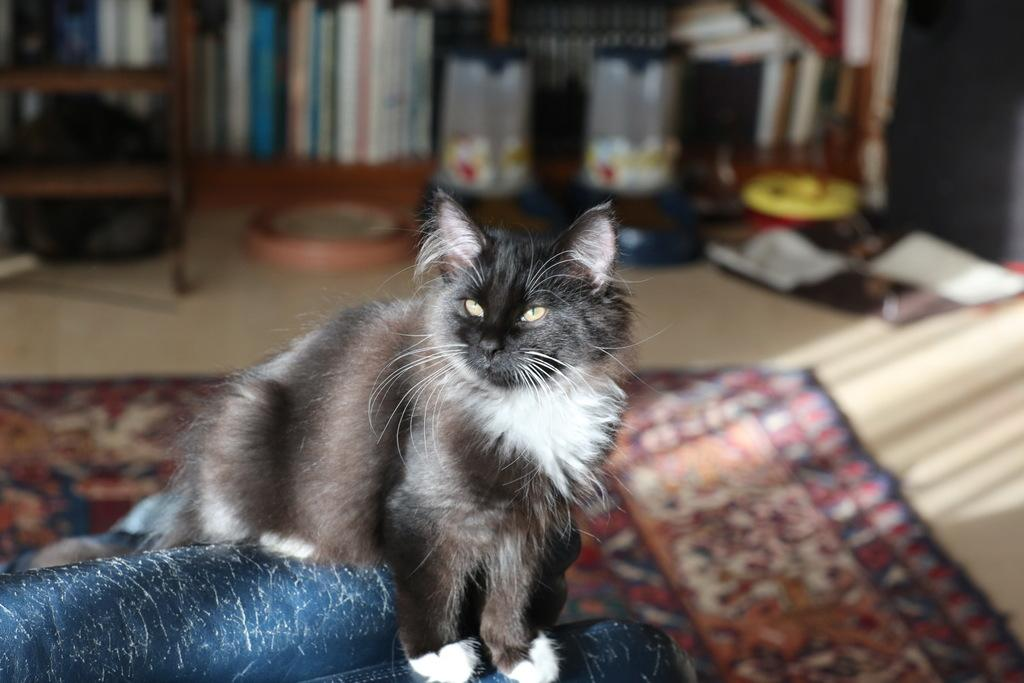What type of animal is present on the surface in the image? There is a cat on the surface in the image. What can be seen in the background of the image? There are books and objects placed on the surface in the background of the image. What is located on the left side of the image? There is a ladder on the left side of the image. What type of verse is being discussed by the cat and the objects in the image? There is no discussion or verse present in the image; it features a cat, books, objects, and a ladder. 